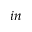Convert formula to latex. <formula><loc_0><loc_0><loc_500><loc_500>i n</formula> 